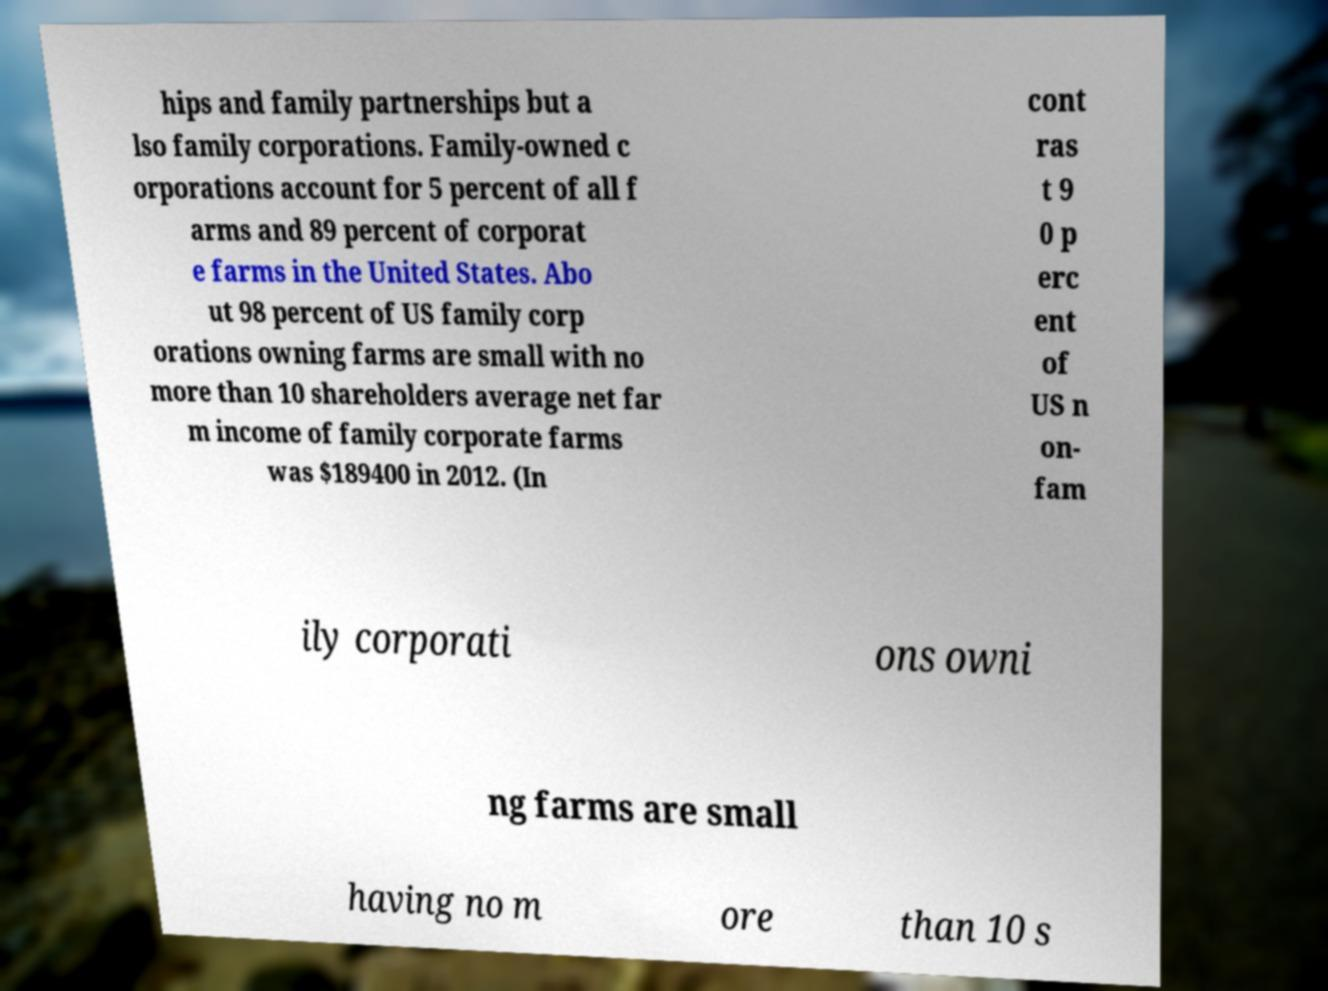Please identify and transcribe the text found in this image. hips and family partnerships but a lso family corporations. Family-owned c orporations account for 5 percent of all f arms and 89 percent of corporat e farms in the United States. Abo ut 98 percent of US family corp orations owning farms are small with no more than 10 shareholders average net far m income of family corporate farms was $189400 in 2012. (In cont ras t 9 0 p erc ent of US n on- fam ily corporati ons owni ng farms are small having no m ore than 10 s 